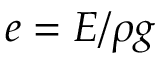Convert formula to latex. <formula><loc_0><loc_0><loc_500><loc_500>e = E / \rho g</formula> 